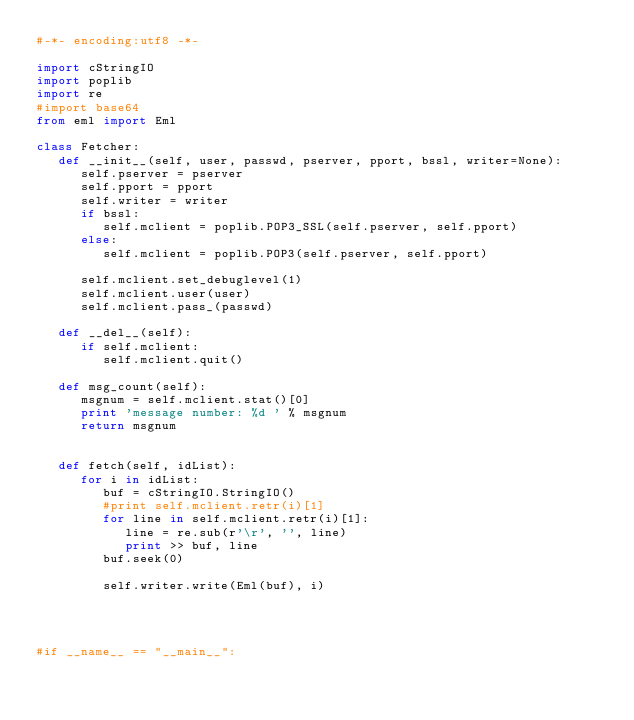Convert code to text. <code><loc_0><loc_0><loc_500><loc_500><_Python_>#-*- encoding:utf8 -*-

import cStringIO
import poplib
import re
#import base64
from eml import Eml

class Fetcher:
   def __init__(self, user, passwd, pserver, pport, bssl, writer=None):
      self.pserver = pserver
      self.pport = pport
      self.writer = writer
      if bssl:
         self.mclient = poplib.POP3_SSL(self.pserver, self.pport)
      else:
         self.mclient = poplib.POP3(self.pserver, self.pport)

      self.mclient.set_debuglevel(1)
      self.mclient.user(user)
      self.mclient.pass_(passwd)
   
   def __del__(self):
      if self.mclient:
         self.mclient.quit()

   def msg_count(self):
      msgnum = self.mclient.stat()[0]
      print 'message number: %d ' % msgnum
      return msgnum


   def fetch(self, idList):
      for i in idList:
         buf = cStringIO.StringIO()
         #print self.mclient.retr(i)[1]
         for line in self.mclient.retr(i)[1]:
            line = re.sub(r'\r', '', line)
            print >> buf, line
         buf.seek(0)

         self.writer.write(Eml(buf), i)




#if __name__ == "__main__":

</code> 